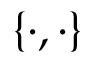<formula> <loc_0><loc_0><loc_500><loc_500>\{ \cdot , \cdot \}</formula> 